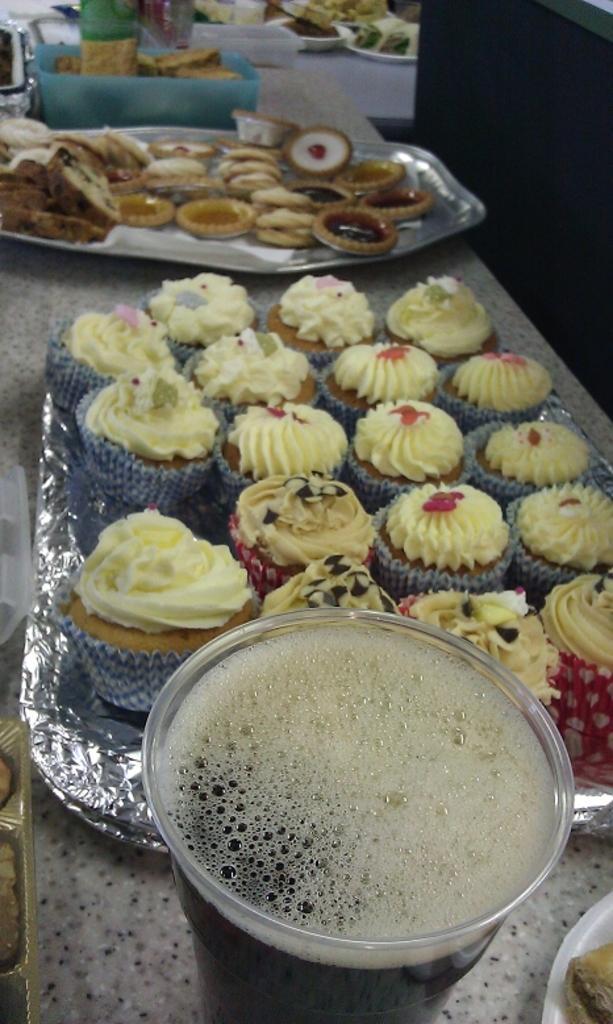In one or two sentences, can you explain what this image depicts? This image consists of cupcakes and a glass of juice along with many food items kept on the desk. 